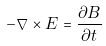<formula> <loc_0><loc_0><loc_500><loc_500>- \nabla \times E = { \frac { \partial B } { \partial t } }</formula> 